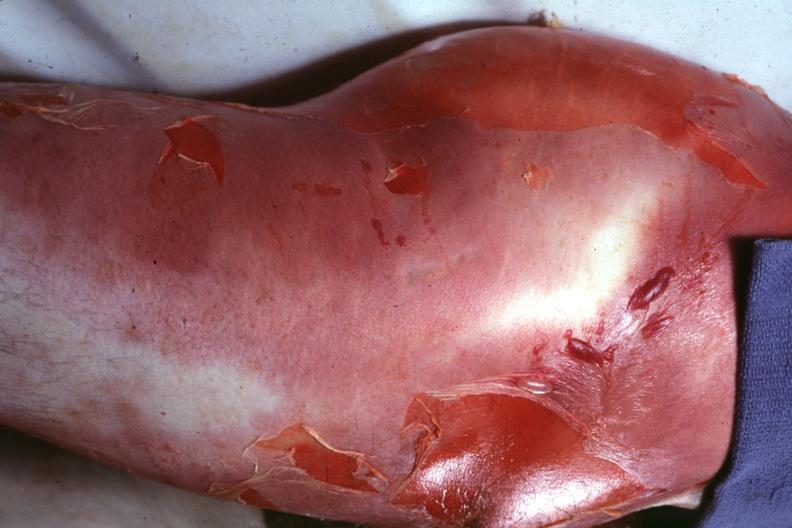where is this?
Answer the question using a single word or phrase. Skin 